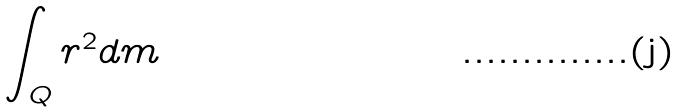<formula> <loc_0><loc_0><loc_500><loc_500>\int _ { Q } r ^ { 2 } d m</formula> 